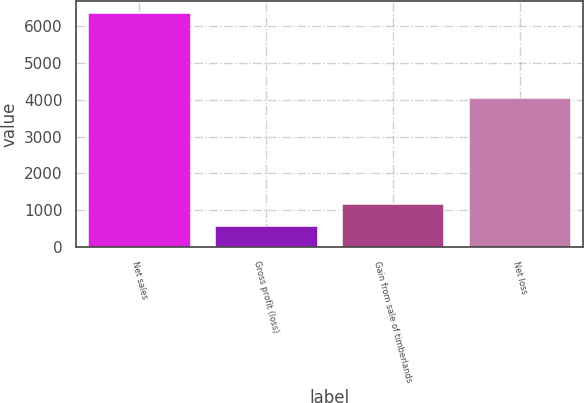Convert chart to OTSL. <chart><loc_0><loc_0><loc_500><loc_500><bar_chart><fcel>Net sales<fcel>Gross profit (loss)<fcel>Gain from sale of timberlands<fcel>Net loss<nl><fcel>6373<fcel>573<fcel>1153<fcel>4045<nl></chart> 